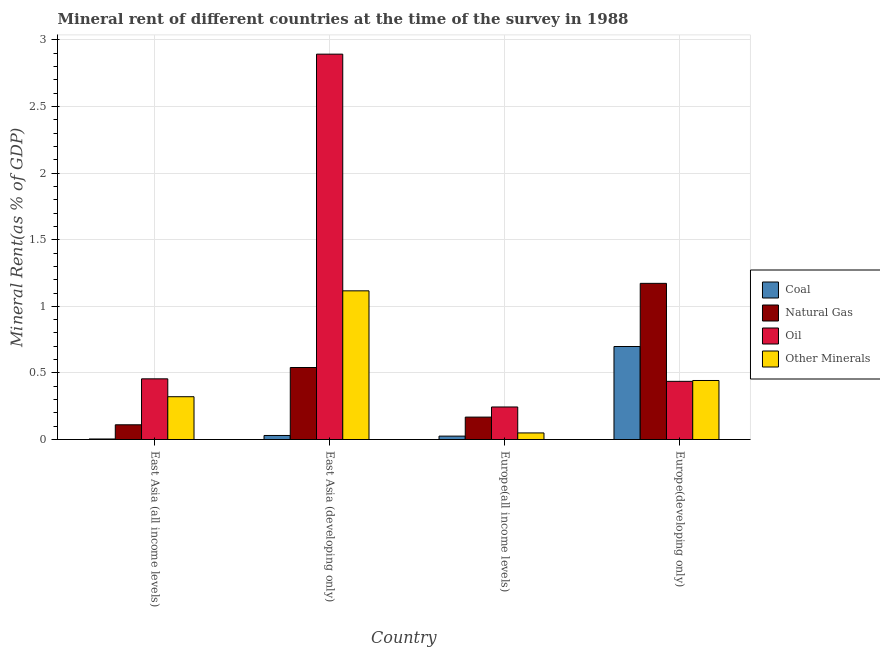How many bars are there on the 4th tick from the left?
Your answer should be very brief. 4. What is the label of the 1st group of bars from the left?
Ensure brevity in your answer.  East Asia (all income levels). In how many cases, is the number of bars for a given country not equal to the number of legend labels?
Make the answer very short. 0. What is the oil rent in East Asia (all income levels)?
Offer a terse response. 0.46. Across all countries, what is the maximum coal rent?
Offer a very short reply. 0.7. Across all countries, what is the minimum natural gas rent?
Your answer should be very brief. 0.11. In which country was the natural gas rent maximum?
Keep it short and to the point. Europe(developing only). In which country was the oil rent minimum?
Provide a succinct answer. Europe(all income levels). What is the total coal rent in the graph?
Make the answer very short. 0.76. What is the difference between the natural gas rent in East Asia (developing only) and that in Europe(developing only)?
Your answer should be very brief. -0.63. What is the difference between the natural gas rent in East Asia (all income levels) and the  rent of other minerals in Europe(developing only)?
Ensure brevity in your answer.  -0.33. What is the average  rent of other minerals per country?
Offer a very short reply. 0.48. What is the difference between the coal rent and natural gas rent in East Asia (all income levels)?
Ensure brevity in your answer.  -0.11. What is the ratio of the  rent of other minerals in East Asia (developing only) to that in Europe(developing only)?
Provide a succinct answer. 2.52. Is the  rent of other minerals in Europe(all income levels) less than that in Europe(developing only)?
Provide a short and direct response. Yes. Is the difference between the natural gas rent in East Asia (all income levels) and Europe(developing only) greater than the difference between the  rent of other minerals in East Asia (all income levels) and Europe(developing only)?
Your answer should be compact. No. What is the difference between the highest and the second highest natural gas rent?
Keep it short and to the point. 0.63. What is the difference between the highest and the lowest coal rent?
Your answer should be compact. 0.69. In how many countries, is the  rent of other minerals greater than the average  rent of other minerals taken over all countries?
Give a very brief answer. 1. Is it the case that in every country, the sum of the oil rent and  rent of other minerals is greater than the sum of natural gas rent and coal rent?
Give a very brief answer. No. What does the 4th bar from the left in Europe(all income levels) represents?
Your answer should be very brief. Other Minerals. What does the 4th bar from the right in East Asia (developing only) represents?
Your response must be concise. Coal. Are all the bars in the graph horizontal?
Give a very brief answer. No. How many countries are there in the graph?
Offer a terse response. 4. What is the difference between two consecutive major ticks on the Y-axis?
Your answer should be very brief. 0.5. Are the values on the major ticks of Y-axis written in scientific E-notation?
Provide a short and direct response. No. What is the title of the graph?
Provide a short and direct response. Mineral rent of different countries at the time of the survey in 1988. What is the label or title of the X-axis?
Offer a very short reply. Country. What is the label or title of the Y-axis?
Offer a terse response. Mineral Rent(as % of GDP). What is the Mineral Rent(as % of GDP) of Coal in East Asia (all income levels)?
Make the answer very short. 0. What is the Mineral Rent(as % of GDP) of Natural Gas in East Asia (all income levels)?
Make the answer very short. 0.11. What is the Mineral Rent(as % of GDP) in Oil in East Asia (all income levels)?
Offer a terse response. 0.46. What is the Mineral Rent(as % of GDP) of Other Minerals in East Asia (all income levels)?
Your answer should be very brief. 0.32. What is the Mineral Rent(as % of GDP) of Coal in East Asia (developing only)?
Ensure brevity in your answer.  0.03. What is the Mineral Rent(as % of GDP) in Natural Gas in East Asia (developing only)?
Give a very brief answer. 0.54. What is the Mineral Rent(as % of GDP) in Oil in East Asia (developing only)?
Keep it short and to the point. 2.89. What is the Mineral Rent(as % of GDP) of Other Minerals in East Asia (developing only)?
Your answer should be very brief. 1.12. What is the Mineral Rent(as % of GDP) in Coal in Europe(all income levels)?
Offer a terse response. 0.03. What is the Mineral Rent(as % of GDP) of Natural Gas in Europe(all income levels)?
Provide a succinct answer. 0.17. What is the Mineral Rent(as % of GDP) of Oil in Europe(all income levels)?
Your answer should be compact. 0.24. What is the Mineral Rent(as % of GDP) of Other Minerals in Europe(all income levels)?
Your response must be concise. 0.05. What is the Mineral Rent(as % of GDP) in Coal in Europe(developing only)?
Your response must be concise. 0.7. What is the Mineral Rent(as % of GDP) of Natural Gas in Europe(developing only)?
Make the answer very short. 1.17. What is the Mineral Rent(as % of GDP) of Oil in Europe(developing only)?
Keep it short and to the point. 0.44. What is the Mineral Rent(as % of GDP) in Other Minerals in Europe(developing only)?
Offer a very short reply. 0.44. Across all countries, what is the maximum Mineral Rent(as % of GDP) of Coal?
Offer a terse response. 0.7. Across all countries, what is the maximum Mineral Rent(as % of GDP) in Natural Gas?
Make the answer very short. 1.17. Across all countries, what is the maximum Mineral Rent(as % of GDP) in Oil?
Keep it short and to the point. 2.89. Across all countries, what is the maximum Mineral Rent(as % of GDP) in Other Minerals?
Give a very brief answer. 1.12. Across all countries, what is the minimum Mineral Rent(as % of GDP) in Coal?
Provide a short and direct response. 0. Across all countries, what is the minimum Mineral Rent(as % of GDP) of Natural Gas?
Provide a short and direct response. 0.11. Across all countries, what is the minimum Mineral Rent(as % of GDP) in Oil?
Your response must be concise. 0.24. Across all countries, what is the minimum Mineral Rent(as % of GDP) in Other Minerals?
Offer a terse response. 0.05. What is the total Mineral Rent(as % of GDP) of Coal in the graph?
Your response must be concise. 0.76. What is the total Mineral Rent(as % of GDP) in Natural Gas in the graph?
Offer a terse response. 1.99. What is the total Mineral Rent(as % of GDP) in Oil in the graph?
Offer a very short reply. 4.03. What is the total Mineral Rent(as % of GDP) in Other Minerals in the graph?
Your answer should be very brief. 1.93. What is the difference between the Mineral Rent(as % of GDP) of Coal in East Asia (all income levels) and that in East Asia (developing only)?
Provide a short and direct response. -0.03. What is the difference between the Mineral Rent(as % of GDP) of Natural Gas in East Asia (all income levels) and that in East Asia (developing only)?
Make the answer very short. -0.43. What is the difference between the Mineral Rent(as % of GDP) of Oil in East Asia (all income levels) and that in East Asia (developing only)?
Provide a short and direct response. -2.44. What is the difference between the Mineral Rent(as % of GDP) of Other Minerals in East Asia (all income levels) and that in East Asia (developing only)?
Make the answer very short. -0.8. What is the difference between the Mineral Rent(as % of GDP) of Coal in East Asia (all income levels) and that in Europe(all income levels)?
Ensure brevity in your answer.  -0.02. What is the difference between the Mineral Rent(as % of GDP) in Natural Gas in East Asia (all income levels) and that in Europe(all income levels)?
Make the answer very short. -0.06. What is the difference between the Mineral Rent(as % of GDP) of Oil in East Asia (all income levels) and that in Europe(all income levels)?
Your response must be concise. 0.21. What is the difference between the Mineral Rent(as % of GDP) of Other Minerals in East Asia (all income levels) and that in Europe(all income levels)?
Provide a succinct answer. 0.27. What is the difference between the Mineral Rent(as % of GDP) in Coal in East Asia (all income levels) and that in Europe(developing only)?
Provide a succinct answer. -0.69. What is the difference between the Mineral Rent(as % of GDP) in Natural Gas in East Asia (all income levels) and that in Europe(developing only)?
Ensure brevity in your answer.  -1.06. What is the difference between the Mineral Rent(as % of GDP) in Oil in East Asia (all income levels) and that in Europe(developing only)?
Your answer should be compact. 0.02. What is the difference between the Mineral Rent(as % of GDP) in Other Minerals in East Asia (all income levels) and that in Europe(developing only)?
Keep it short and to the point. -0.12. What is the difference between the Mineral Rent(as % of GDP) of Coal in East Asia (developing only) and that in Europe(all income levels)?
Give a very brief answer. 0. What is the difference between the Mineral Rent(as % of GDP) of Natural Gas in East Asia (developing only) and that in Europe(all income levels)?
Your answer should be compact. 0.37. What is the difference between the Mineral Rent(as % of GDP) in Oil in East Asia (developing only) and that in Europe(all income levels)?
Make the answer very short. 2.65. What is the difference between the Mineral Rent(as % of GDP) of Other Minerals in East Asia (developing only) and that in Europe(all income levels)?
Keep it short and to the point. 1.07. What is the difference between the Mineral Rent(as % of GDP) of Coal in East Asia (developing only) and that in Europe(developing only)?
Make the answer very short. -0.67. What is the difference between the Mineral Rent(as % of GDP) of Natural Gas in East Asia (developing only) and that in Europe(developing only)?
Keep it short and to the point. -0.63. What is the difference between the Mineral Rent(as % of GDP) of Oil in East Asia (developing only) and that in Europe(developing only)?
Give a very brief answer. 2.46. What is the difference between the Mineral Rent(as % of GDP) in Other Minerals in East Asia (developing only) and that in Europe(developing only)?
Your answer should be very brief. 0.67. What is the difference between the Mineral Rent(as % of GDP) of Coal in Europe(all income levels) and that in Europe(developing only)?
Your response must be concise. -0.67. What is the difference between the Mineral Rent(as % of GDP) of Natural Gas in Europe(all income levels) and that in Europe(developing only)?
Your answer should be very brief. -1. What is the difference between the Mineral Rent(as % of GDP) in Oil in Europe(all income levels) and that in Europe(developing only)?
Your response must be concise. -0.19. What is the difference between the Mineral Rent(as % of GDP) of Other Minerals in Europe(all income levels) and that in Europe(developing only)?
Your response must be concise. -0.39. What is the difference between the Mineral Rent(as % of GDP) in Coal in East Asia (all income levels) and the Mineral Rent(as % of GDP) in Natural Gas in East Asia (developing only)?
Offer a terse response. -0.54. What is the difference between the Mineral Rent(as % of GDP) of Coal in East Asia (all income levels) and the Mineral Rent(as % of GDP) of Oil in East Asia (developing only)?
Your answer should be very brief. -2.89. What is the difference between the Mineral Rent(as % of GDP) in Coal in East Asia (all income levels) and the Mineral Rent(as % of GDP) in Other Minerals in East Asia (developing only)?
Your answer should be compact. -1.11. What is the difference between the Mineral Rent(as % of GDP) in Natural Gas in East Asia (all income levels) and the Mineral Rent(as % of GDP) in Oil in East Asia (developing only)?
Provide a succinct answer. -2.78. What is the difference between the Mineral Rent(as % of GDP) in Natural Gas in East Asia (all income levels) and the Mineral Rent(as % of GDP) in Other Minerals in East Asia (developing only)?
Provide a succinct answer. -1.01. What is the difference between the Mineral Rent(as % of GDP) in Oil in East Asia (all income levels) and the Mineral Rent(as % of GDP) in Other Minerals in East Asia (developing only)?
Keep it short and to the point. -0.66. What is the difference between the Mineral Rent(as % of GDP) in Coal in East Asia (all income levels) and the Mineral Rent(as % of GDP) in Natural Gas in Europe(all income levels)?
Offer a very short reply. -0.16. What is the difference between the Mineral Rent(as % of GDP) in Coal in East Asia (all income levels) and the Mineral Rent(as % of GDP) in Oil in Europe(all income levels)?
Keep it short and to the point. -0.24. What is the difference between the Mineral Rent(as % of GDP) in Coal in East Asia (all income levels) and the Mineral Rent(as % of GDP) in Other Minerals in Europe(all income levels)?
Your answer should be compact. -0.05. What is the difference between the Mineral Rent(as % of GDP) in Natural Gas in East Asia (all income levels) and the Mineral Rent(as % of GDP) in Oil in Europe(all income levels)?
Provide a short and direct response. -0.13. What is the difference between the Mineral Rent(as % of GDP) of Natural Gas in East Asia (all income levels) and the Mineral Rent(as % of GDP) of Other Minerals in Europe(all income levels)?
Ensure brevity in your answer.  0.06. What is the difference between the Mineral Rent(as % of GDP) in Oil in East Asia (all income levels) and the Mineral Rent(as % of GDP) in Other Minerals in Europe(all income levels)?
Your answer should be very brief. 0.41. What is the difference between the Mineral Rent(as % of GDP) in Coal in East Asia (all income levels) and the Mineral Rent(as % of GDP) in Natural Gas in Europe(developing only)?
Ensure brevity in your answer.  -1.17. What is the difference between the Mineral Rent(as % of GDP) in Coal in East Asia (all income levels) and the Mineral Rent(as % of GDP) in Oil in Europe(developing only)?
Ensure brevity in your answer.  -0.43. What is the difference between the Mineral Rent(as % of GDP) in Coal in East Asia (all income levels) and the Mineral Rent(as % of GDP) in Other Minerals in Europe(developing only)?
Offer a terse response. -0.44. What is the difference between the Mineral Rent(as % of GDP) in Natural Gas in East Asia (all income levels) and the Mineral Rent(as % of GDP) in Oil in Europe(developing only)?
Your response must be concise. -0.33. What is the difference between the Mineral Rent(as % of GDP) in Natural Gas in East Asia (all income levels) and the Mineral Rent(as % of GDP) in Other Minerals in Europe(developing only)?
Your answer should be compact. -0.33. What is the difference between the Mineral Rent(as % of GDP) in Oil in East Asia (all income levels) and the Mineral Rent(as % of GDP) in Other Minerals in Europe(developing only)?
Your response must be concise. 0.01. What is the difference between the Mineral Rent(as % of GDP) of Coal in East Asia (developing only) and the Mineral Rent(as % of GDP) of Natural Gas in Europe(all income levels)?
Offer a very short reply. -0.14. What is the difference between the Mineral Rent(as % of GDP) in Coal in East Asia (developing only) and the Mineral Rent(as % of GDP) in Oil in Europe(all income levels)?
Provide a short and direct response. -0.21. What is the difference between the Mineral Rent(as % of GDP) of Coal in East Asia (developing only) and the Mineral Rent(as % of GDP) of Other Minerals in Europe(all income levels)?
Give a very brief answer. -0.02. What is the difference between the Mineral Rent(as % of GDP) in Natural Gas in East Asia (developing only) and the Mineral Rent(as % of GDP) in Oil in Europe(all income levels)?
Provide a succinct answer. 0.3. What is the difference between the Mineral Rent(as % of GDP) in Natural Gas in East Asia (developing only) and the Mineral Rent(as % of GDP) in Other Minerals in Europe(all income levels)?
Your response must be concise. 0.49. What is the difference between the Mineral Rent(as % of GDP) in Oil in East Asia (developing only) and the Mineral Rent(as % of GDP) in Other Minerals in Europe(all income levels)?
Ensure brevity in your answer.  2.84. What is the difference between the Mineral Rent(as % of GDP) of Coal in East Asia (developing only) and the Mineral Rent(as % of GDP) of Natural Gas in Europe(developing only)?
Your answer should be very brief. -1.14. What is the difference between the Mineral Rent(as % of GDP) in Coal in East Asia (developing only) and the Mineral Rent(as % of GDP) in Oil in Europe(developing only)?
Ensure brevity in your answer.  -0.41. What is the difference between the Mineral Rent(as % of GDP) of Coal in East Asia (developing only) and the Mineral Rent(as % of GDP) of Other Minerals in Europe(developing only)?
Ensure brevity in your answer.  -0.41. What is the difference between the Mineral Rent(as % of GDP) of Natural Gas in East Asia (developing only) and the Mineral Rent(as % of GDP) of Oil in Europe(developing only)?
Provide a short and direct response. 0.1. What is the difference between the Mineral Rent(as % of GDP) of Natural Gas in East Asia (developing only) and the Mineral Rent(as % of GDP) of Other Minerals in Europe(developing only)?
Your response must be concise. 0.1. What is the difference between the Mineral Rent(as % of GDP) of Oil in East Asia (developing only) and the Mineral Rent(as % of GDP) of Other Minerals in Europe(developing only)?
Ensure brevity in your answer.  2.45. What is the difference between the Mineral Rent(as % of GDP) in Coal in Europe(all income levels) and the Mineral Rent(as % of GDP) in Natural Gas in Europe(developing only)?
Ensure brevity in your answer.  -1.15. What is the difference between the Mineral Rent(as % of GDP) in Coal in Europe(all income levels) and the Mineral Rent(as % of GDP) in Oil in Europe(developing only)?
Provide a succinct answer. -0.41. What is the difference between the Mineral Rent(as % of GDP) in Coal in Europe(all income levels) and the Mineral Rent(as % of GDP) in Other Minerals in Europe(developing only)?
Offer a very short reply. -0.42. What is the difference between the Mineral Rent(as % of GDP) of Natural Gas in Europe(all income levels) and the Mineral Rent(as % of GDP) of Oil in Europe(developing only)?
Keep it short and to the point. -0.27. What is the difference between the Mineral Rent(as % of GDP) in Natural Gas in Europe(all income levels) and the Mineral Rent(as % of GDP) in Other Minerals in Europe(developing only)?
Offer a very short reply. -0.27. What is the difference between the Mineral Rent(as % of GDP) in Oil in Europe(all income levels) and the Mineral Rent(as % of GDP) in Other Minerals in Europe(developing only)?
Offer a very short reply. -0.2. What is the average Mineral Rent(as % of GDP) of Coal per country?
Make the answer very short. 0.19. What is the average Mineral Rent(as % of GDP) of Natural Gas per country?
Offer a very short reply. 0.5. What is the average Mineral Rent(as % of GDP) of Oil per country?
Ensure brevity in your answer.  1.01. What is the average Mineral Rent(as % of GDP) in Other Minerals per country?
Make the answer very short. 0.48. What is the difference between the Mineral Rent(as % of GDP) in Coal and Mineral Rent(as % of GDP) in Natural Gas in East Asia (all income levels)?
Give a very brief answer. -0.11. What is the difference between the Mineral Rent(as % of GDP) of Coal and Mineral Rent(as % of GDP) of Oil in East Asia (all income levels)?
Ensure brevity in your answer.  -0.45. What is the difference between the Mineral Rent(as % of GDP) in Coal and Mineral Rent(as % of GDP) in Other Minerals in East Asia (all income levels)?
Make the answer very short. -0.32. What is the difference between the Mineral Rent(as % of GDP) of Natural Gas and Mineral Rent(as % of GDP) of Oil in East Asia (all income levels)?
Give a very brief answer. -0.34. What is the difference between the Mineral Rent(as % of GDP) in Natural Gas and Mineral Rent(as % of GDP) in Other Minerals in East Asia (all income levels)?
Your answer should be compact. -0.21. What is the difference between the Mineral Rent(as % of GDP) of Oil and Mineral Rent(as % of GDP) of Other Minerals in East Asia (all income levels)?
Your answer should be compact. 0.13. What is the difference between the Mineral Rent(as % of GDP) in Coal and Mineral Rent(as % of GDP) in Natural Gas in East Asia (developing only)?
Provide a succinct answer. -0.51. What is the difference between the Mineral Rent(as % of GDP) in Coal and Mineral Rent(as % of GDP) in Oil in East Asia (developing only)?
Make the answer very short. -2.86. What is the difference between the Mineral Rent(as % of GDP) of Coal and Mineral Rent(as % of GDP) of Other Minerals in East Asia (developing only)?
Provide a succinct answer. -1.09. What is the difference between the Mineral Rent(as % of GDP) in Natural Gas and Mineral Rent(as % of GDP) in Oil in East Asia (developing only)?
Ensure brevity in your answer.  -2.35. What is the difference between the Mineral Rent(as % of GDP) of Natural Gas and Mineral Rent(as % of GDP) of Other Minerals in East Asia (developing only)?
Ensure brevity in your answer.  -0.58. What is the difference between the Mineral Rent(as % of GDP) of Oil and Mineral Rent(as % of GDP) of Other Minerals in East Asia (developing only)?
Provide a short and direct response. 1.78. What is the difference between the Mineral Rent(as % of GDP) of Coal and Mineral Rent(as % of GDP) of Natural Gas in Europe(all income levels)?
Your response must be concise. -0.14. What is the difference between the Mineral Rent(as % of GDP) of Coal and Mineral Rent(as % of GDP) of Oil in Europe(all income levels)?
Provide a succinct answer. -0.22. What is the difference between the Mineral Rent(as % of GDP) of Coal and Mineral Rent(as % of GDP) of Other Minerals in Europe(all income levels)?
Make the answer very short. -0.02. What is the difference between the Mineral Rent(as % of GDP) of Natural Gas and Mineral Rent(as % of GDP) of Oil in Europe(all income levels)?
Your answer should be very brief. -0.08. What is the difference between the Mineral Rent(as % of GDP) in Natural Gas and Mineral Rent(as % of GDP) in Other Minerals in Europe(all income levels)?
Your answer should be compact. 0.12. What is the difference between the Mineral Rent(as % of GDP) of Oil and Mineral Rent(as % of GDP) of Other Minerals in Europe(all income levels)?
Provide a short and direct response. 0.19. What is the difference between the Mineral Rent(as % of GDP) of Coal and Mineral Rent(as % of GDP) of Natural Gas in Europe(developing only)?
Keep it short and to the point. -0.47. What is the difference between the Mineral Rent(as % of GDP) of Coal and Mineral Rent(as % of GDP) of Oil in Europe(developing only)?
Provide a short and direct response. 0.26. What is the difference between the Mineral Rent(as % of GDP) in Coal and Mineral Rent(as % of GDP) in Other Minerals in Europe(developing only)?
Provide a short and direct response. 0.26. What is the difference between the Mineral Rent(as % of GDP) of Natural Gas and Mineral Rent(as % of GDP) of Oil in Europe(developing only)?
Offer a terse response. 0.74. What is the difference between the Mineral Rent(as % of GDP) of Natural Gas and Mineral Rent(as % of GDP) of Other Minerals in Europe(developing only)?
Your answer should be compact. 0.73. What is the difference between the Mineral Rent(as % of GDP) of Oil and Mineral Rent(as % of GDP) of Other Minerals in Europe(developing only)?
Make the answer very short. -0.01. What is the ratio of the Mineral Rent(as % of GDP) of Coal in East Asia (all income levels) to that in East Asia (developing only)?
Offer a very short reply. 0.13. What is the ratio of the Mineral Rent(as % of GDP) of Natural Gas in East Asia (all income levels) to that in East Asia (developing only)?
Give a very brief answer. 0.2. What is the ratio of the Mineral Rent(as % of GDP) of Oil in East Asia (all income levels) to that in East Asia (developing only)?
Your answer should be compact. 0.16. What is the ratio of the Mineral Rent(as % of GDP) in Other Minerals in East Asia (all income levels) to that in East Asia (developing only)?
Ensure brevity in your answer.  0.29. What is the ratio of the Mineral Rent(as % of GDP) of Coal in East Asia (all income levels) to that in Europe(all income levels)?
Make the answer very short. 0.16. What is the ratio of the Mineral Rent(as % of GDP) of Natural Gas in East Asia (all income levels) to that in Europe(all income levels)?
Offer a very short reply. 0.66. What is the ratio of the Mineral Rent(as % of GDP) in Oil in East Asia (all income levels) to that in Europe(all income levels)?
Your response must be concise. 1.86. What is the ratio of the Mineral Rent(as % of GDP) of Other Minerals in East Asia (all income levels) to that in Europe(all income levels)?
Your response must be concise. 6.5. What is the ratio of the Mineral Rent(as % of GDP) of Coal in East Asia (all income levels) to that in Europe(developing only)?
Your response must be concise. 0.01. What is the ratio of the Mineral Rent(as % of GDP) in Natural Gas in East Asia (all income levels) to that in Europe(developing only)?
Your answer should be compact. 0.09. What is the ratio of the Mineral Rent(as % of GDP) of Oil in East Asia (all income levels) to that in Europe(developing only)?
Offer a terse response. 1.04. What is the ratio of the Mineral Rent(as % of GDP) in Other Minerals in East Asia (all income levels) to that in Europe(developing only)?
Keep it short and to the point. 0.73. What is the ratio of the Mineral Rent(as % of GDP) in Coal in East Asia (developing only) to that in Europe(all income levels)?
Make the answer very short. 1.19. What is the ratio of the Mineral Rent(as % of GDP) in Natural Gas in East Asia (developing only) to that in Europe(all income levels)?
Provide a short and direct response. 3.21. What is the ratio of the Mineral Rent(as % of GDP) in Oil in East Asia (developing only) to that in Europe(all income levels)?
Offer a very short reply. 11.84. What is the ratio of the Mineral Rent(as % of GDP) in Other Minerals in East Asia (developing only) to that in Europe(all income levels)?
Offer a very short reply. 22.56. What is the ratio of the Mineral Rent(as % of GDP) in Coal in East Asia (developing only) to that in Europe(developing only)?
Provide a succinct answer. 0.04. What is the ratio of the Mineral Rent(as % of GDP) of Natural Gas in East Asia (developing only) to that in Europe(developing only)?
Make the answer very short. 0.46. What is the ratio of the Mineral Rent(as % of GDP) of Oil in East Asia (developing only) to that in Europe(developing only)?
Your answer should be compact. 6.62. What is the ratio of the Mineral Rent(as % of GDP) in Other Minerals in East Asia (developing only) to that in Europe(developing only)?
Give a very brief answer. 2.52. What is the ratio of the Mineral Rent(as % of GDP) in Coal in Europe(all income levels) to that in Europe(developing only)?
Offer a very short reply. 0.04. What is the ratio of the Mineral Rent(as % of GDP) in Natural Gas in Europe(all income levels) to that in Europe(developing only)?
Offer a very short reply. 0.14. What is the ratio of the Mineral Rent(as % of GDP) in Oil in Europe(all income levels) to that in Europe(developing only)?
Your answer should be compact. 0.56. What is the ratio of the Mineral Rent(as % of GDP) of Other Minerals in Europe(all income levels) to that in Europe(developing only)?
Your response must be concise. 0.11. What is the difference between the highest and the second highest Mineral Rent(as % of GDP) in Coal?
Keep it short and to the point. 0.67. What is the difference between the highest and the second highest Mineral Rent(as % of GDP) of Natural Gas?
Keep it short and to the point. 0.63. What is the difference between the highest and the second highest Mineral Rent(as % of GDP) of Oil?
Ensure brevity in your answer.  2.44. What is the difference between the highest and the second highest Mineral Rent(as % of GDP) in Other Minerals?
Make the answer very short. 0.67. What is the difference between the highest and the lowest Mineral Rent(as % of GDP) in Coal?
Your response must be concise. 0.69. What is the difference between the highest and the lowest Mineral Rent(as % of GDP) in Natural Gas?
Offer a very short reply. 1.06. What is the difference between the highest and the lowest Mineral Rent(as % of GDP) in Oil?
Offer a very short reply. 2.65. What is the difference between the highest and the lowest Mineral Rent(as % of GDP) in Other Minerals?
Give a very brief answer. 1.07. 